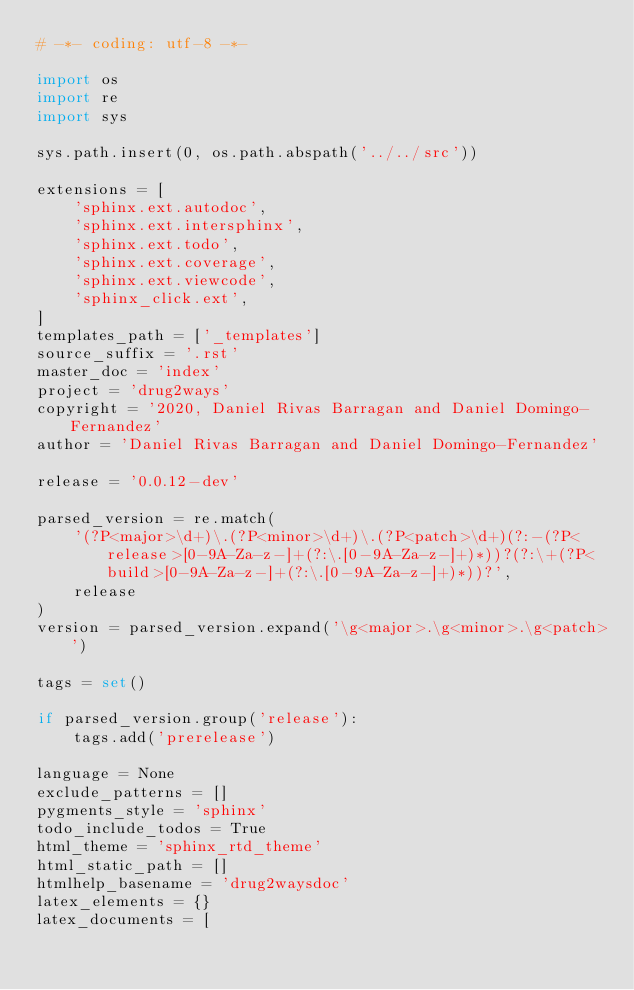Convert code to text. <code><loc_0><loc_0><loc_500><loc_500><_Python_># -*- coding: utf-8 -*-

import os
import re
import sys

sys.path.insert(0, os.path.abspath('../../src'))

extensions = [
    'sphinx.ext.autodoc',
    'sphinx.ext.intersphinx',
    'sphinx.ext.todo',
    'sphinx.ext.coverage',
    'sphinx.ext.viewcode',
    'sphinx_click.ext',
]
templates_path = ['_templates']
source_suffix = '.rst'
master_doc = 'index'
project = 'drug2ways'
copyright = '2020, Daniel Rivas Barragan and Daniel Domingo-Fernandez'
author = 'Daniel Rivas Barragan and Daniel Domingo-Fernandez'

release = '0.0.12-dev'

parsed_version = re.match(
    '(?P<major>\d+)\.(?P<minor>\d+)\.(?P<patch>\d+)(?:-(?P<release>[0-9A-Za-z-]+(?:\.[0-9A-Za-z-]+)*))?(?:\+(?P<build>[0-9A-Za-z-]+(?:\.[0-9A-Za-z-]+)*))?',
    release
)
version = parsed_version.expand('\g<major>.\g<minor>.\g<patch>')

tags = set()

if parsed_version.group('release'):
    tags.add('prerelease')

language = None
exclude_patterns = []
pygments_style = 'sphinx'
todo_include_todos = True
html_theme = 'sphinx_rtd_theme'
html_static_path = []
htmlhelp_basename = 'drug2waysdoc'
latex_elements = {}
latex_documents = [</code> 